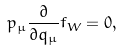Convert formula to latex. <formula><loc_0><loc_0><loc_500><loc_500>p _ { \mu } \frac { \partial } { \partial q _ { \mu } } f _ { W } = 0 ,</formula> 